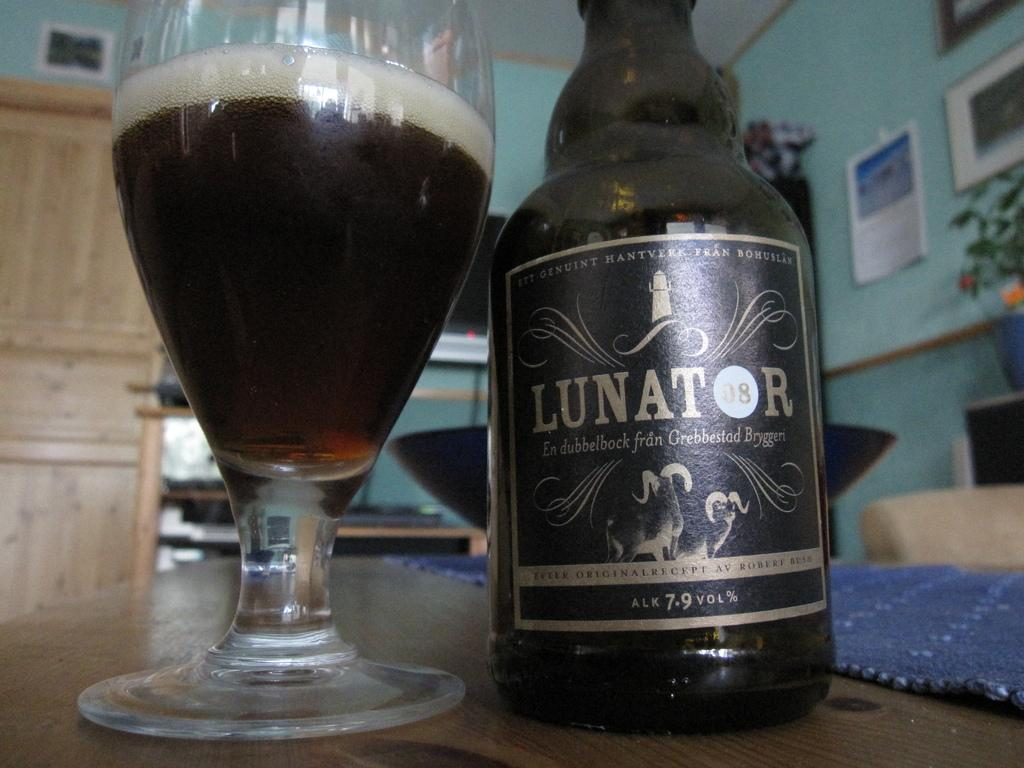<image>
Write a terse but informative summary of the picture. "LUNATOR" is on the label of a black bottle. 